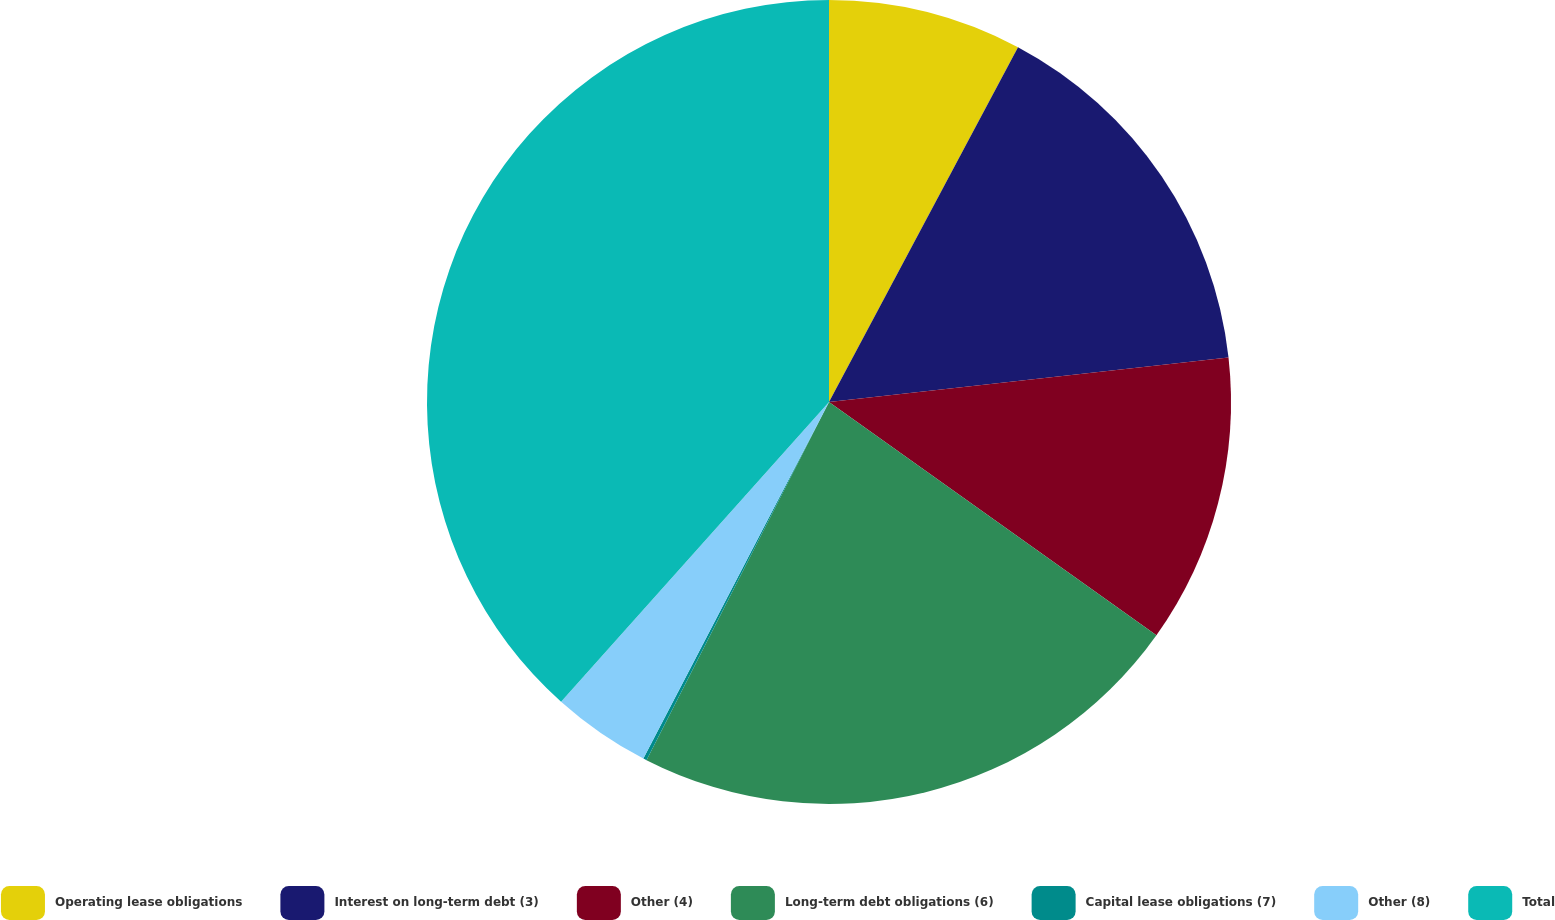<chart> <loc_0><loc_0><loc_500><loc_500><pie_chart><fcel>Operating lease obligations<fcel>Interest on long-term debt (3)<fcel>Other (4)<fcel>Long-term debt obligations (6)<fcel>Capital lease obligations (7)<fcel>Other (8)<fcel>Total<nl><fcel>7.79%<fcel>15.44%<fcel>11.62%<fcel>22.65%<fcel>0.14%<fcel>3.97%<fcel>38.39%<nl></chart> 